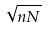<formula> <loc_0><loc_0><loc_500><loc_500>\sqrt { n N }</formula> 